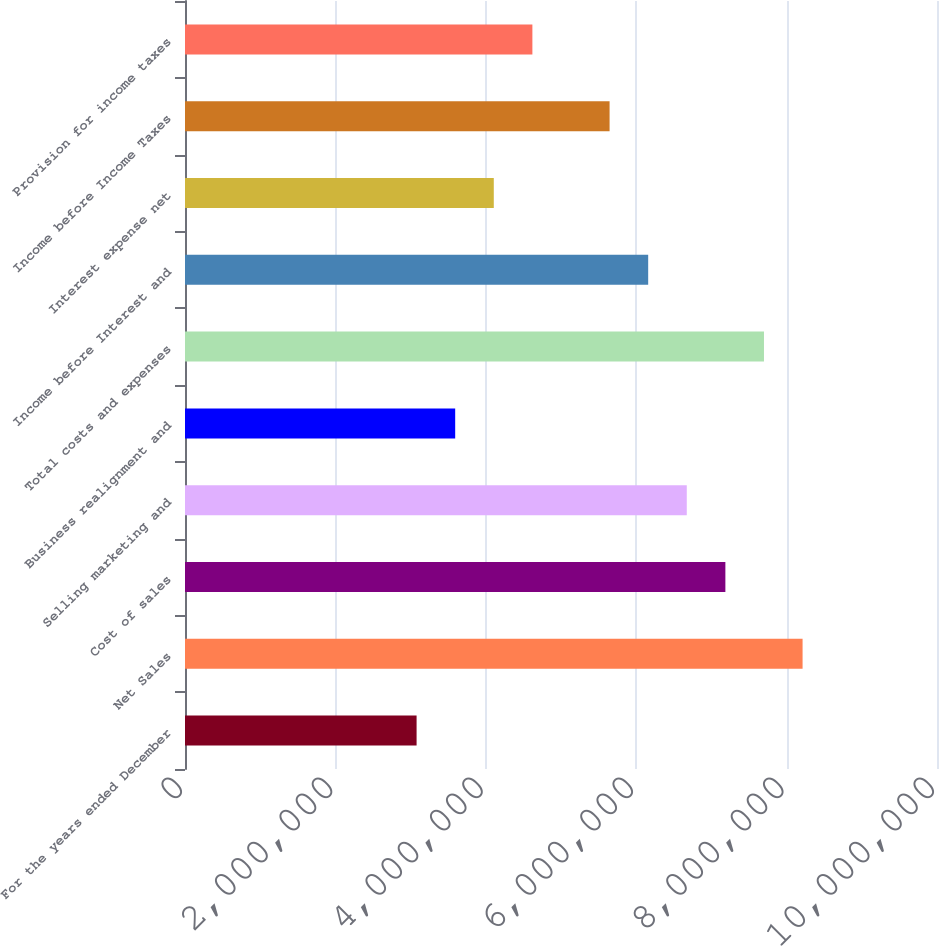Convert chart to OTSL. <chart><loc_0><loc_0><loc_500><loc_500><bar_chart><fcel>For the years ended December<fcel>Net Sales<fcel>Cost of sales<fcel>Selling marketing and<fcel>Business realignment and<fcel>Total costs and expenses<fcel>Income before Interest and<fcel>Interest expense net<fcel>Income before Income Taxes<fcel>Provision for income taxes<nl><fcel>3.07966e+06<fcel>8.21243e+06<fcel>7.18587e+06<fcel>6.6726e+06<fcel>3.59294e+06<fcel>7.69915e+06<fcel>6.15932e+06<fcel>4.10621e+06<fcel>5.64604e+06<fcel>4.61949e+06<nl></chart> 